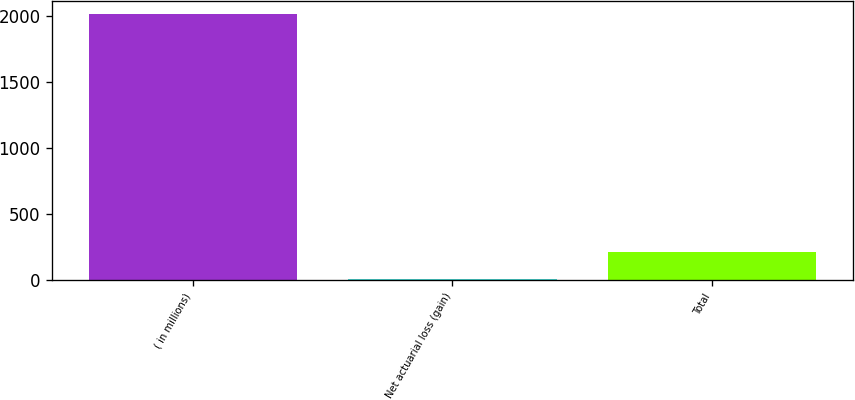Convert chart. <chart><loc_0><loc_0><loc_500><loc_500><bar_chart><fcel>( in millions)<fcel>Net actuarial loss (gain)<fcel>Total<nl><fcel>2016<fcel>11.9<fcel>212.31<nl></chart> 